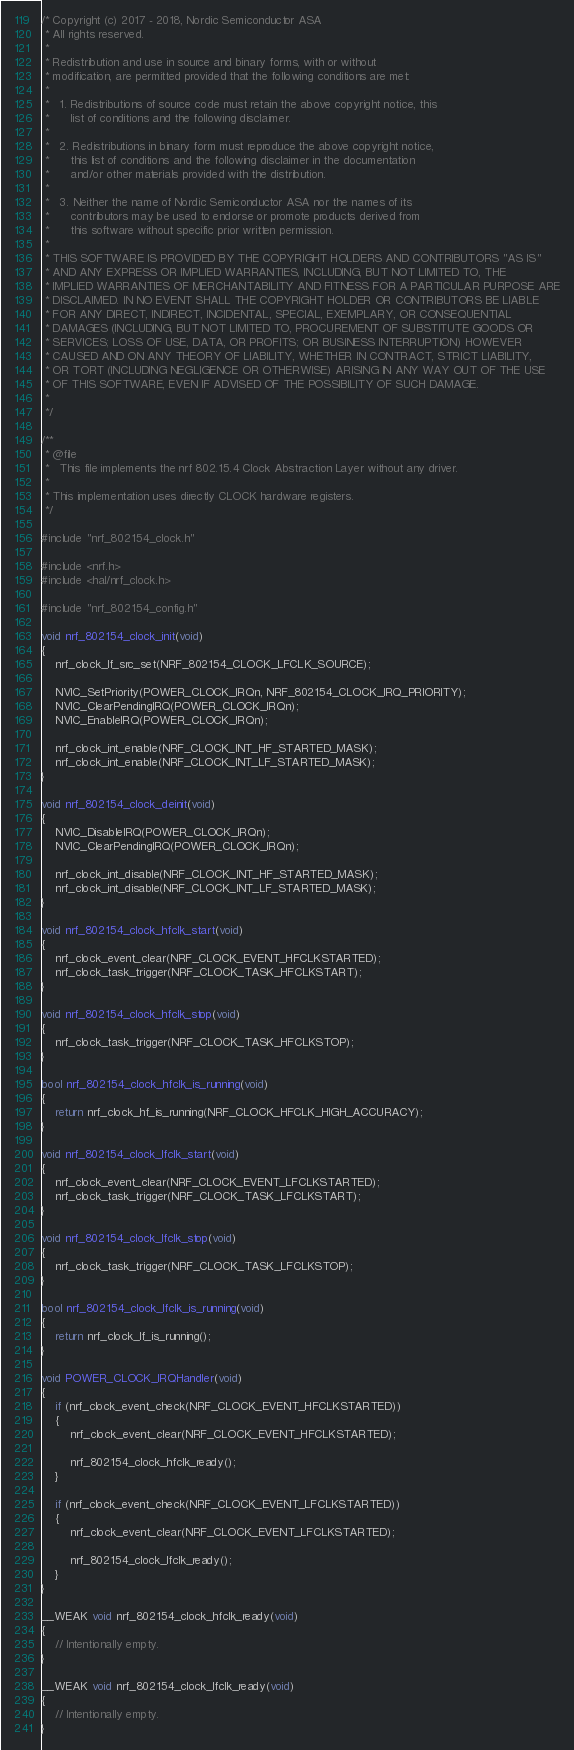<code> <loc_0><loc_0><loc_500><loc_500><_C_>/* Copyright (c) 2017 - 2018, Nordic Semiconductor ASA
 * All rights reserved.
 *
 * Redistribution and use in source and binary forms, with or without
 * modification, are permitted provided that the following conditions are met:
 *
 *   1. Redistributions of source code must retain the above copyright notice, this
 *      list of conditions and the following disclaimer.
 *
 *   2. Redistributions in binary form must reproduce the above copyright notice,
 *      this list of conditions and the following disclaimer in the documentation
 *      and/or other materials provided with the distribution.
 *
 *   3. Neither the name of Nordic Semiconductor ASA nor the names of its
 *      contributors may be used to endorse or promote products derived from
 *      this software without specific prior written permission.
 *
 * THIS SOFTWARE IS PROVIDED BY THE COPYRIGHT HOLDERS AND CONTRIBUTORS "AS IS"
 * AND ANY EXPRESS OR IMPLIED WARRANTIES, INCLUDING, BUT NOT LIMITED TO, THE
 * IMPLIED WARRANTIES OF MERCHANTABILITY AND FITNESS FOR A PARTICULAR PURPOSE ARE
 * DISCLAIMED. IN NO EVENT SHALL THE COPYRIGHT HOLDER OR CONTRIBUTORS BE LIABLE
 * FOR ANY DIRECT, INDIRECT, INCIDENTAL, SPECIAL, EXEMPLARY, OR CONSEQUENTIAL
 * DAMAGES (INCLUDING, BUT NOT LIMITED TO, PROCUREMENT OF SUBSTITUTE GOODS OR
 * SERVICES; LOSS OF USE, DATA, OR PROFITS; OR BUSINESS INTERRUPTION) HOWEVER
 * CAUSED AND ON ANY THEORY OF LIABILITY, WHETHER IN CONTRACT, STRICT LIABILITY,
 * OR TORT (INCLUDING NEGLIGENCE OR OTHERWISE) ARISING IN ANY WAY OUT OF THE USE
 * OF THIS SOFTWARE, EVEN IF ADVISED OF THE POSSIBILITY OF SUCH DAMAGE.
 *
 */

/**
 * @file
 *   This file implements the nrf 802.15.4 Clock Abstraction Layer without any driver.
 *
 * This implementation uses directly CLOCK hardware registers.
 */

#include "nrf_802154_clock.h"

#include <nrf.h>
#include <hal/nrf_clock.h>

#include "nrf_802154_config.h"

void nrf_802154_clock_init(void)
{
    nrf_clock_lf_src_set(NRF_802154_CLOCK_LFCLK_SOURCE);

    NVIC_SetPriority(POWER_CLOCK_IRQn, NRF_802154_CLOCK_IRQ_PRIORITY);
    NVIC_ClearPendingIRQ(POWER_CLOCK_IRQn);
    NVIC_EnableIRQ(POWER_CLOCK_IRQn);

    nrf_clock_int_enable(NRF_CLOCK_INT_HF_STARTED_MASK);
    nrf_clock_int_enable(NRF_CLOCK_INT_LF_STARTED_MASK);
}

void nrf_802154_clock_deinit(void)
{
    NVIC_DisableIRQ(POWER_CLOCK_IRQn);
    NVIC_ClearPendingIRQ(POWER_CLOCK_IRQn);

    nrf_clock_int_disable(NRF_CLOCK_INT_HF_STARTED_MASK);
    nrf_clock_int_disable(NRF_CLOCK_INT_LF_STARTED_MASK);
}

void nrf_802154_clock_hfclk_start(void)
{
    nrf_clock_event_clear(NRF_CLOCK_EVENT_HFCLKSTARTED);
    nrf_clock_task_trigger(NRF_CLOCK_TASK_HFCLKSTART);
}

void nrf_802154_clock_hfclk_stop(void)
{
    nrf_clock_task_trigger(NRF_CLOCK_TASK_HFCLKSTOP);
}

bool nrf_802154_clock_hfclk_is_running(void)
{
    return nrf_clock_hf_is_running(NRF_CLOCK_HFCLK_HIGH_ACCURACY);
}

void nrf_802154_clock_lfclk_start(void)
{
    nrf_clock_event_clear(NRF_CLOCK_EVENT_LFCLKSTARTED);
    nrf_clock_task_trigger(NRF_CLOCK_TASK_LFCLKSTART);
}

void nrf_802154_clock_lfclk_stop(void)
{
    nrf_clock_task_trigger(NRF_CLOCK_TASK_LFCLKSTOP);
}

bool nrf_802154_clock_lfclk_is_running(void)
{
    return nrf_clock_lf_is_running();
}

void POWER_CLOCK_IRQHandler(void)
{
    if (nrf_clock_event_check(NRF_CLOCK_EVENT_HFCLKSTARTED))
    {
        nrf_clock_event_clear(NRF_CLOCK_EVENT_HFCLKSTARTED);

        nrf_802154_clock_hfclk_ready();
    }

    if (nrf_clock_event_check(NRF_CLOCK_EVENT_LFCLKSTARTED))
    {
        nrf_clock_event_clear(NRF_CLOCK_EVENT_LFCLKSTARTED);

        nrf_802154_clock_lfclk_ready();
    }
}

__WEAK void nrf_802154_clock_hfclk_ready(void)
{
    // Intentionally empty.
}

__WEAK void nrf_802154_clock_lfclk_ready(void)
{
    // Intentionally empty.
}
</code> 